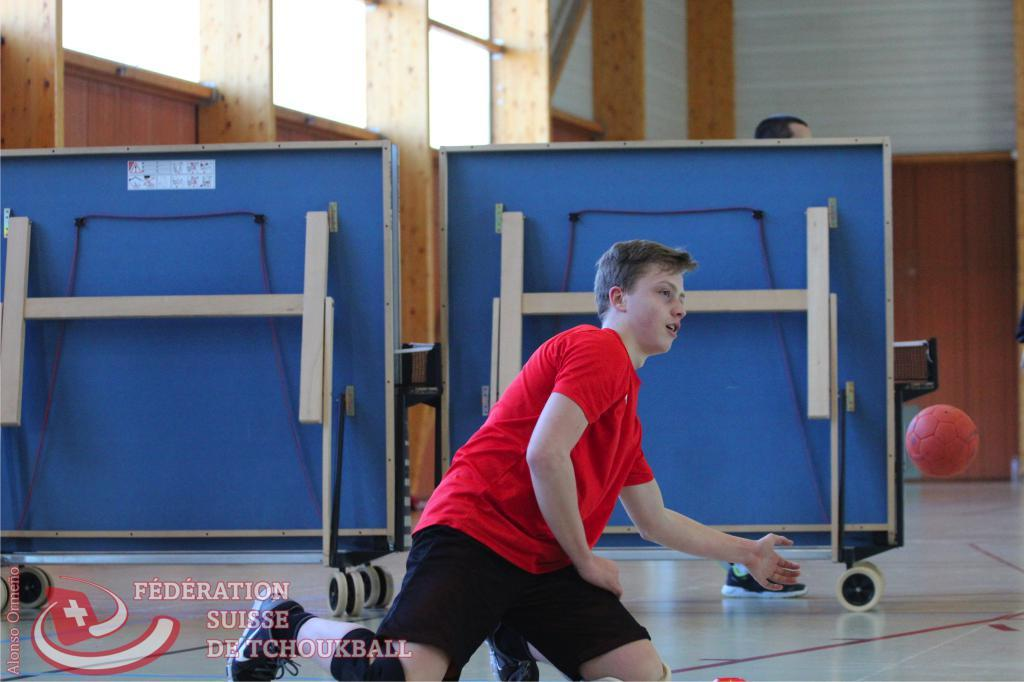<image>
Share a concise interpretation of the image provided. A man practices handball with the text Federation Suisse De Tchoukball shown on the screen. 